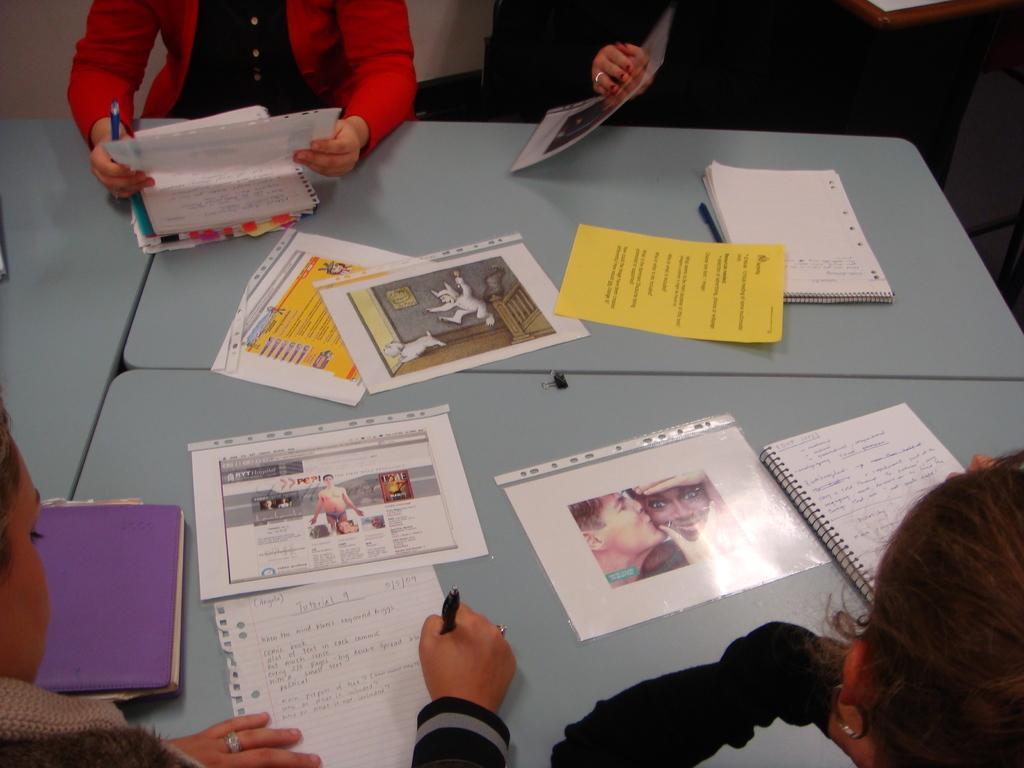How would you summarize this image in a sentence or two? In this image, I can see the hands of four persons. There is a table with papers, pen and books on it. At the top of the image, I can see two persons holding papers. At the bottom left side of the image, I can see another person writing on a paper. 